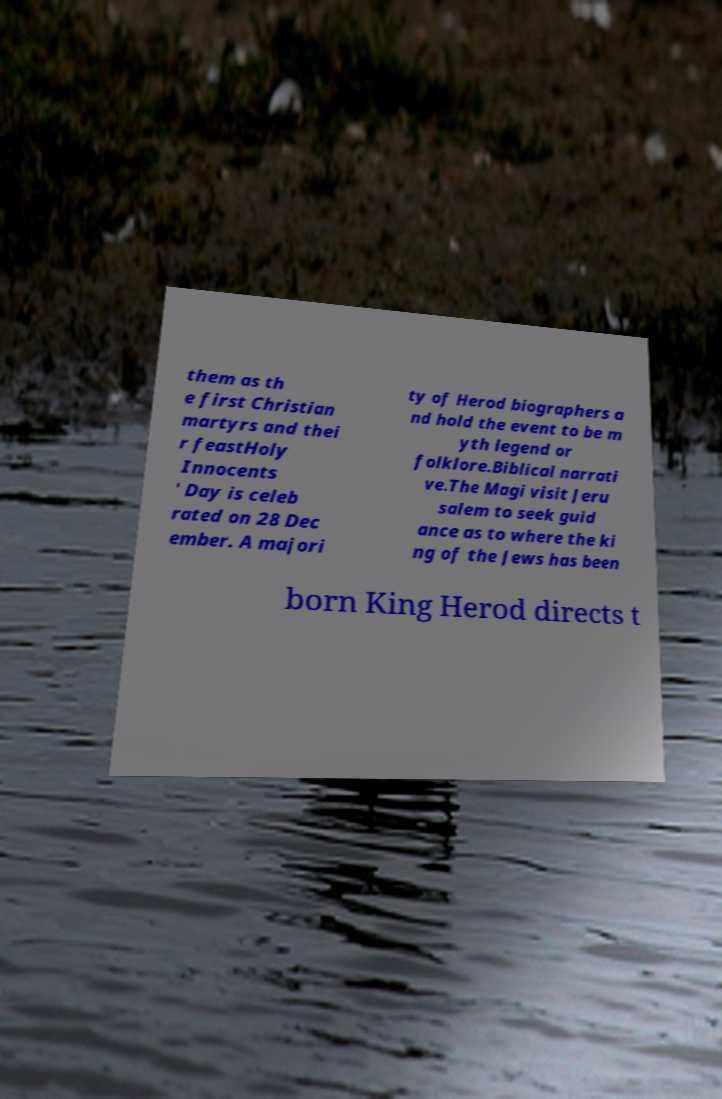I need the written content from this picture converted into text. Can you do that? them as th e first Christian martyrs and thei r feastHoly Innocents ' Day is celeb rated on 28 Dec ember. A majori ty of Herod biographers a nd hold the event to be m yth legend or folklore.Biblical narrati ve.The Magi visit Jeru salem to seek guid ance as to where the ki ng of the Jews has been born King Herod directs t 